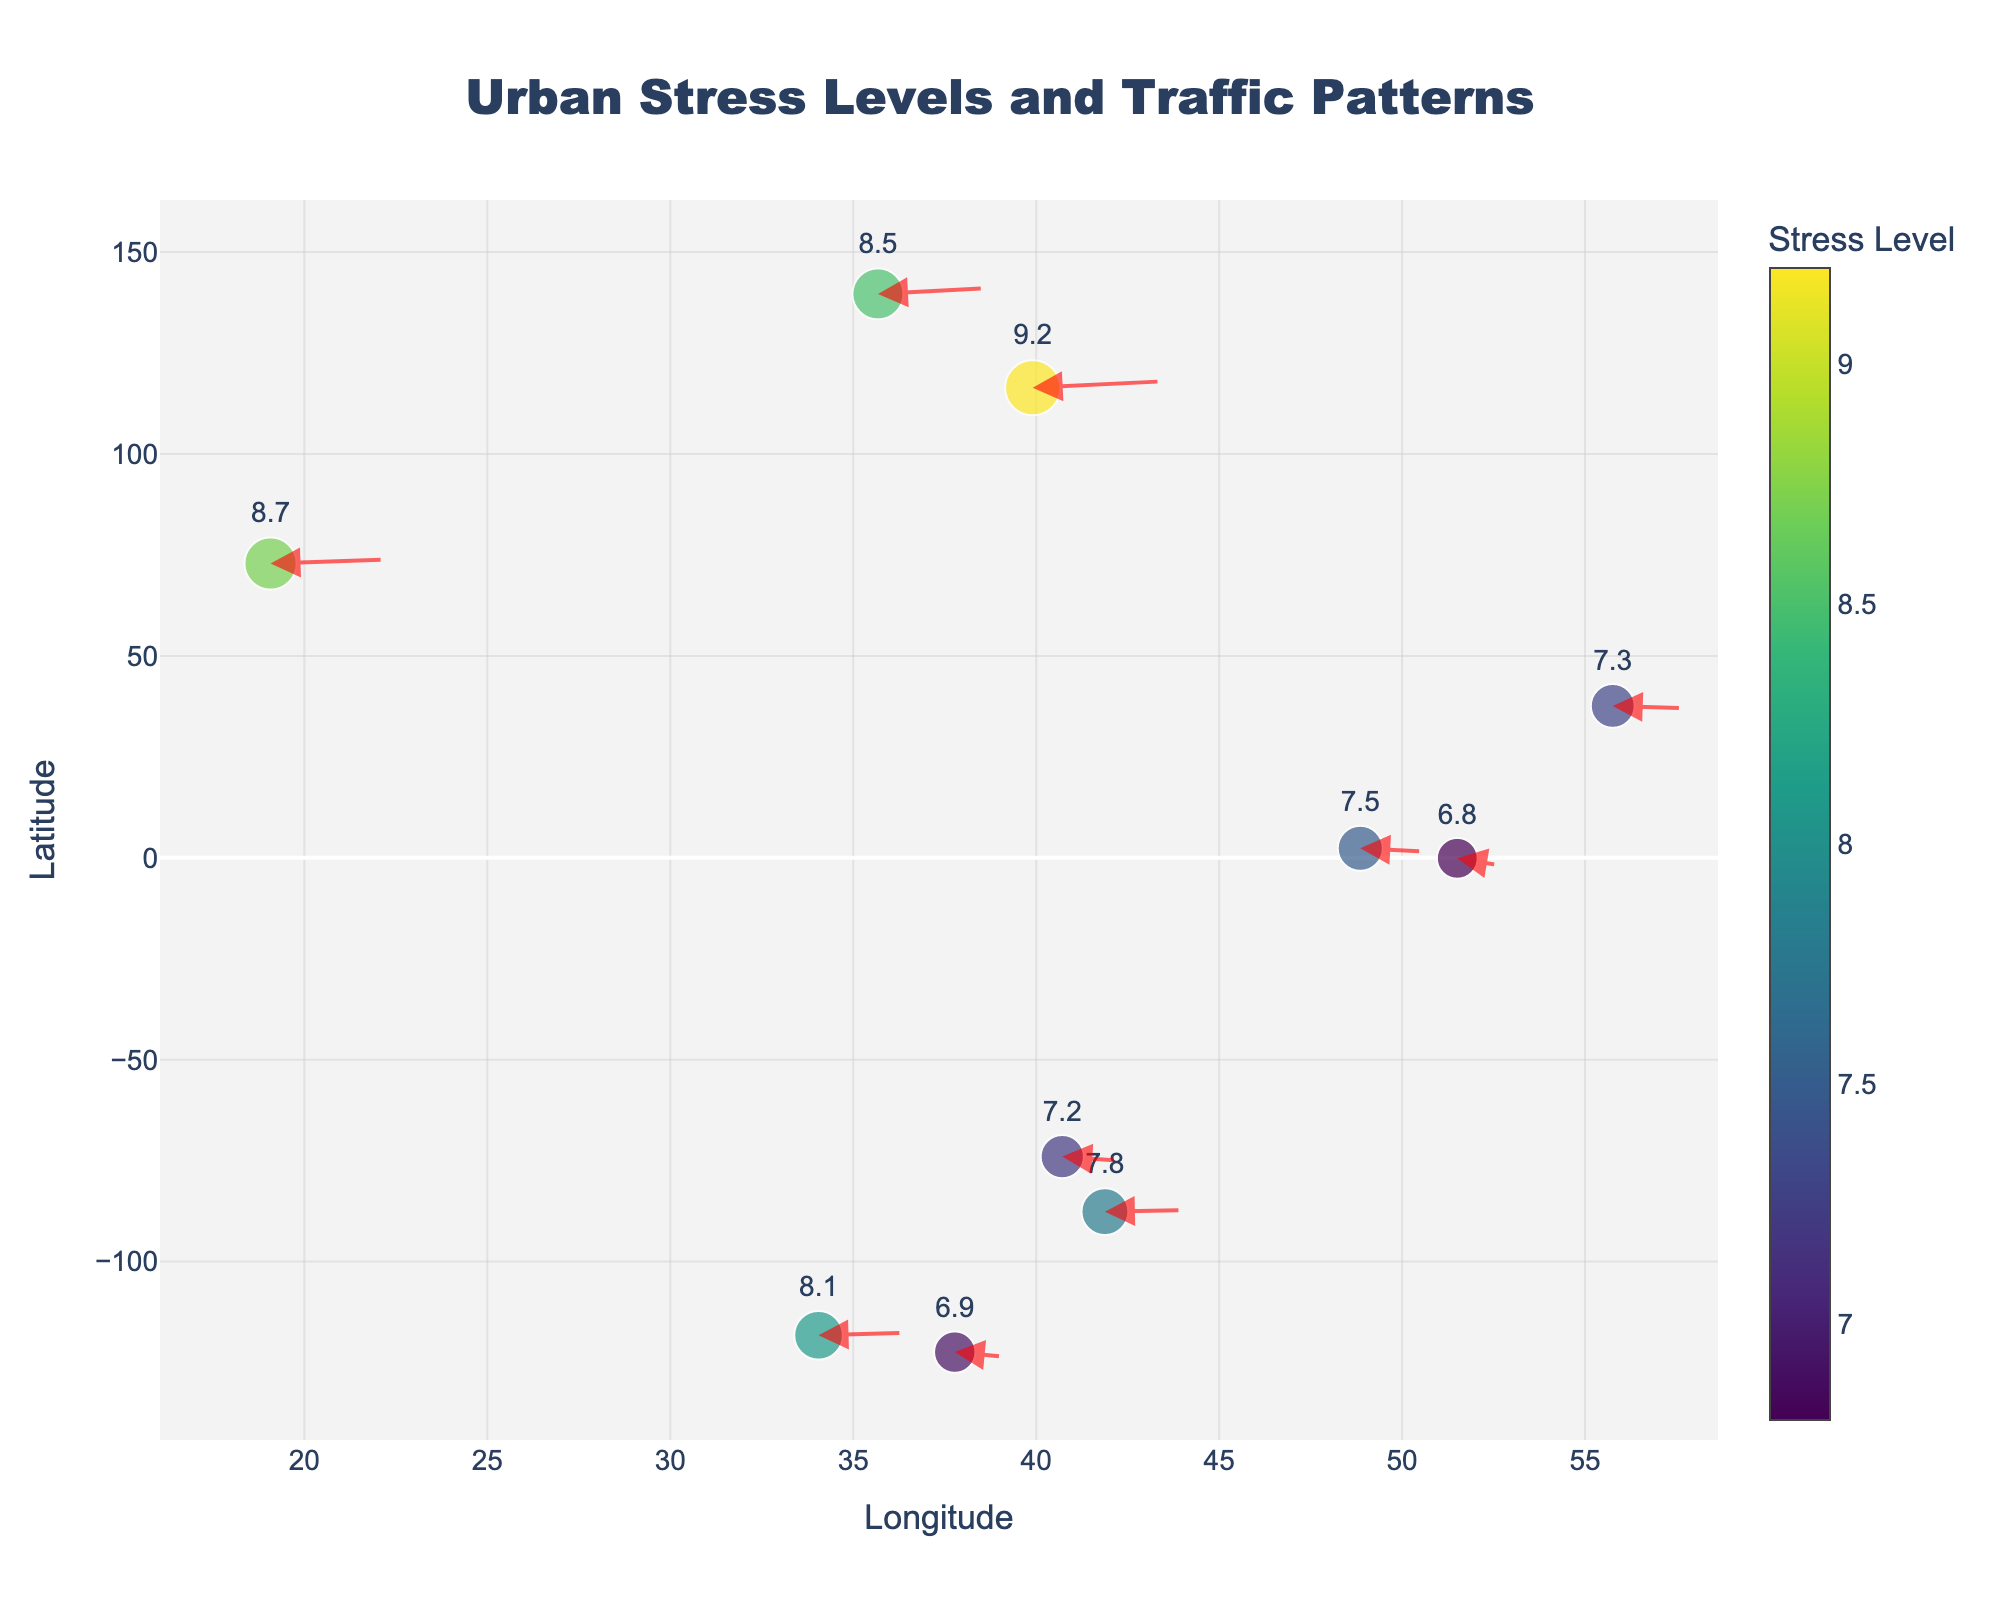What is the title of the figure? The title is displayed on the top of the figure and provides a brief description of the content. Look at the figure's top center above where the data points are plotted.
Answer: Urban Stress Levels and Traffic Patterns How many data points (cities) are presented in the figure? The data points correspond to the number of markers on the plot. Count the number of distinct marker symbols plotted on the figure.
Answer: 10 Which city shows the highest stress level and what is the level? The stress levels are indicated by both the size and color intensity of the markers. The largest and darkest-colored marker represents the highest stress level. The stress level values are also displayed next to the markers.
Answer: Beijing, 9.2 What is the average stress level across all cities? Sum the stress levels of all cities and divide by the total number of cities (10). The stress levels are listed as 7.2, 8.1, 6.8, 8.5, 7.5, 7.8, 6.9, 9.2, 8.7, 7.3. The sum is 77.0, so the average is 77.0 / 10.
Answer: 7.7 Which cities have stress levels above 8 and what are their respective levels? Identify the markers with stress levels higher than 8 by checking the text labels beside each marker.
Answer: Los Angeles (8.1), Tokyo (8.5), Beijing (9.2), and Mumbai (8.7) Which city has the lowest stress level, and what is the direction and magnitude of its arrow? The smallest marker with the lightest color represents the lowest stress level. Examine the arrow direction and length from this marker. This city is London with a stress level of 6.8 and the direction can be seen by the red arrow originating from London's point.
Answer: London, 6.8, direction (-0.6,-1.8) How does the stress level in New York compare to Paris? Look at the markers for New York and Paris and read the stress level values displayed. New York's stress level is 7.2 and Paris's is 7.5. Compare these values directly.
Answer: New York's stress level is lower than Paris's What is the difference between the stress levels in the city with the highest stress level and the city with the lowest stress level? Identify the highest and lowest stress levels, which are 9.2 (Beijing) and 6.8 (London) respectively. Subtract the lowest from the highest to find the difference.
Answer: 2.4 Describe the pattern of the arrows in the figure relative to traffic congestion and noise pollution. The arrows indicate the direction and magnitude of the impact of traffic and noise pollution on stress levels. Observe the overall direction (either increasing or decreasing) and length of the arrows. The arrows generally trend upwards towards higher stress levels, indicating that increased traffic and noise lead to higher stress.
Answer: Generally upwards in higher stress cities 